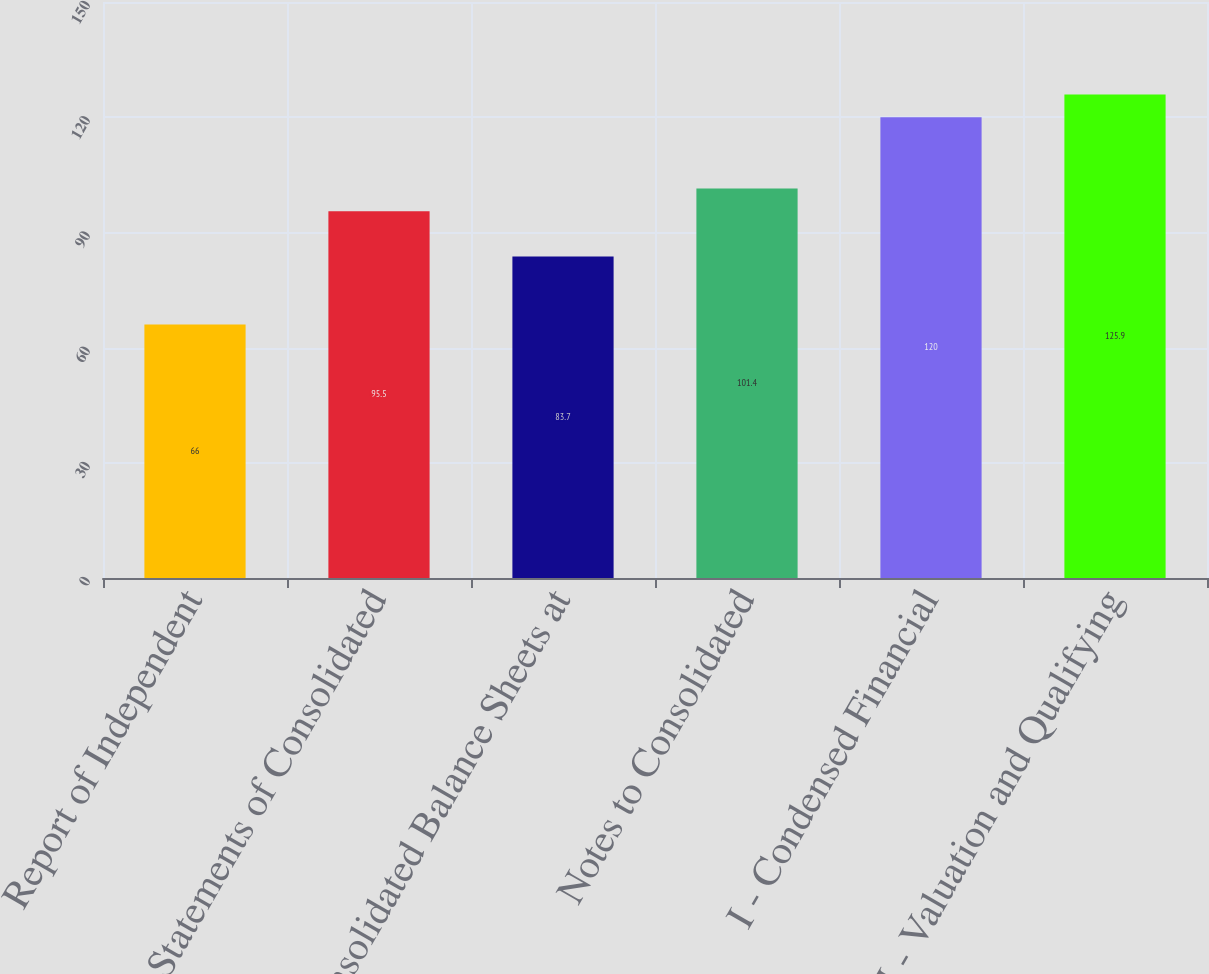Convert chart to OTSL. <chart><loc_0><loc_0><loc_500><loc_500><bar_chart><fcel>Report of Independent<fcel>Statements of Consolidated<fcel>Consolidated Balance Sheets at<fcel>Notes to Consolidated<fcel>I - Condensed Financial<fcel>II - Valuation and Qualifying<nl><fcel>66<fcel>95.5<fcel>83.7<fcel>101.4<fcel>120<fcel>125.9<nl></chart> 